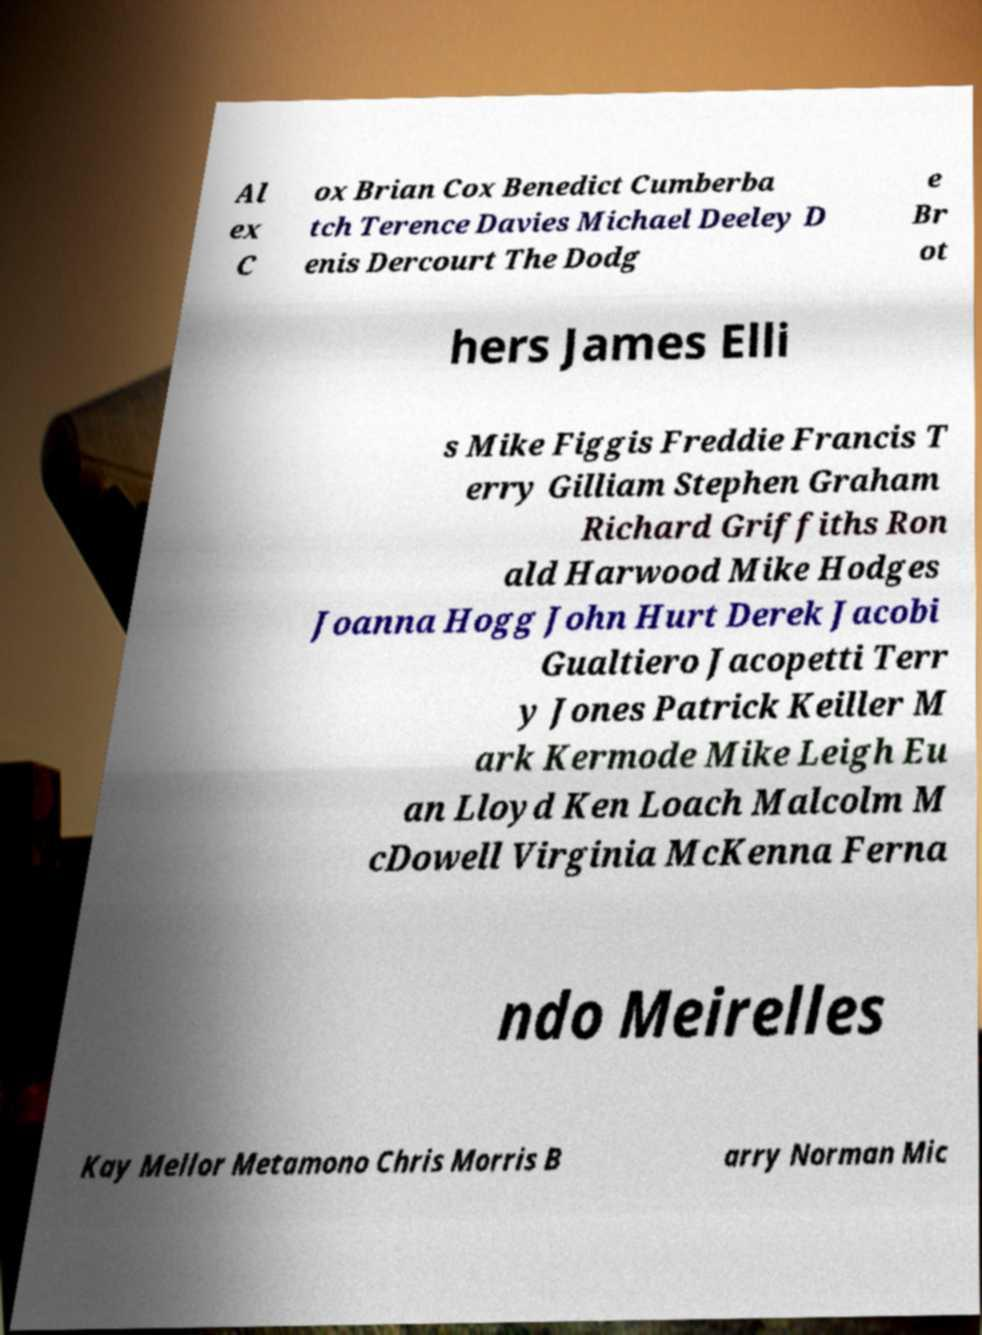Can you accurately transcribe the text from the provided image for me? Al ex C ox Brian Cox Benedict Cumberba tch Terence Davies Michael Deeley D enis Dercourt The Dodg e Br ot hers James Elli s Mike Figgis Freddie Francis T erry Gilliam Stephen Graham Richard Griffiths Ron ald Harwood Mike Hodges Joanna Hogg John Hurt Derek Jacobi Gualtiero Jacopetti Terr y Jones Patrick Keiller M ark Kermode Mike Leigh Eu an Lloyd Ken Loach Malcolm M cDowell Virginia McKenna Ferna ndo Meirelles Kay Mellor Metamono Chris Morris B arry Norman Mic 